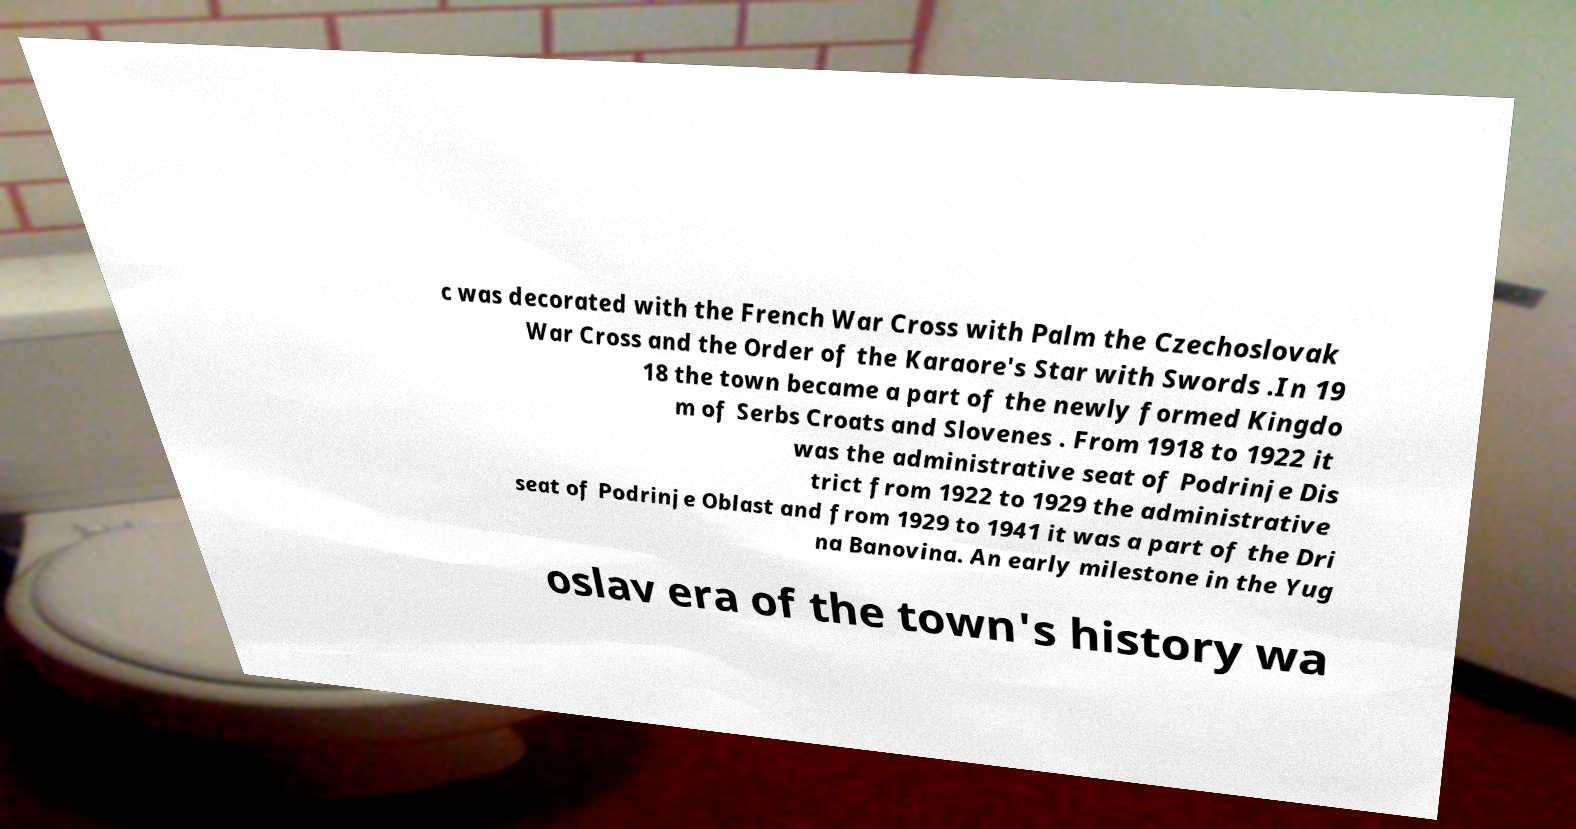Could you assist in decoding the text presented in this image and type it out clearly? c was decorated with the French War Cross with Palm the Czechoslovak War Cross and the Order of the Karaore's Star with Swords .In 19 18 the town became a part of the newly formed Kingdo m of Serbs Croats and Slovenes . From 1918 to 1922 it was the administrative seat of Podrinje Dis trict from 1922 to 1929 the administrative seat of Podrinje Oblast and from 1929 to 1941 it was a part of the Dri na Banovina. An early milestone in the Yug oslav era of the town's history wa 